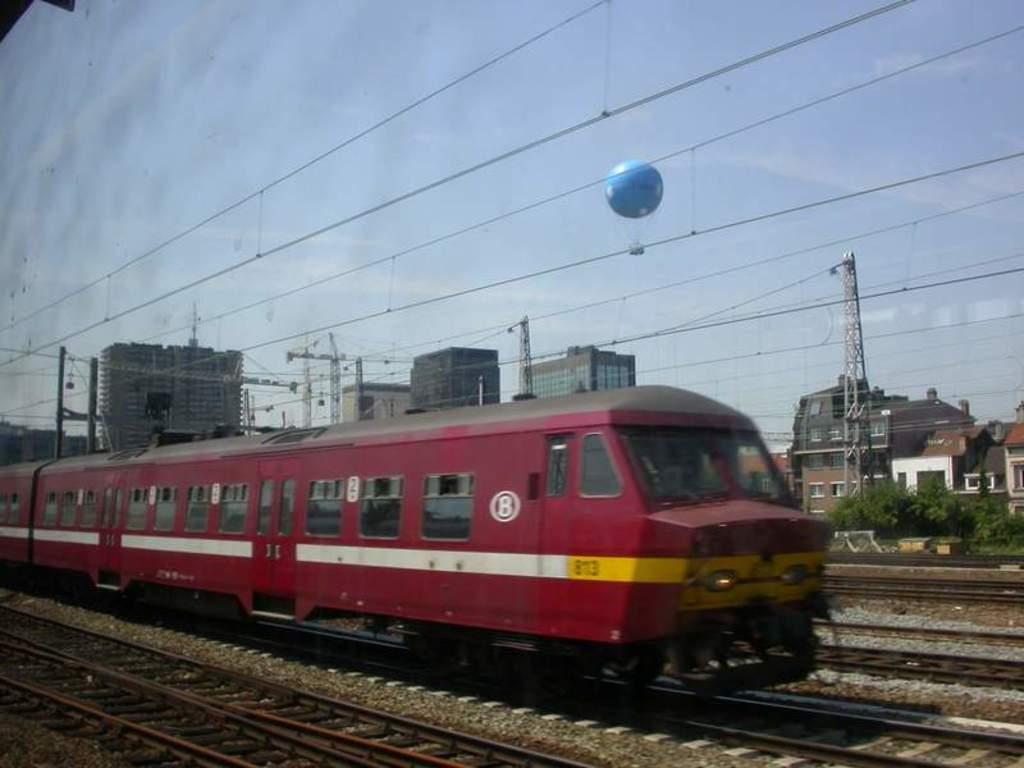Can you describe this image briefly? In this image we can see the train and there are railway tracks. And at the side, we can see there are buildings, trees, antennas and parachute flying in the sky. 